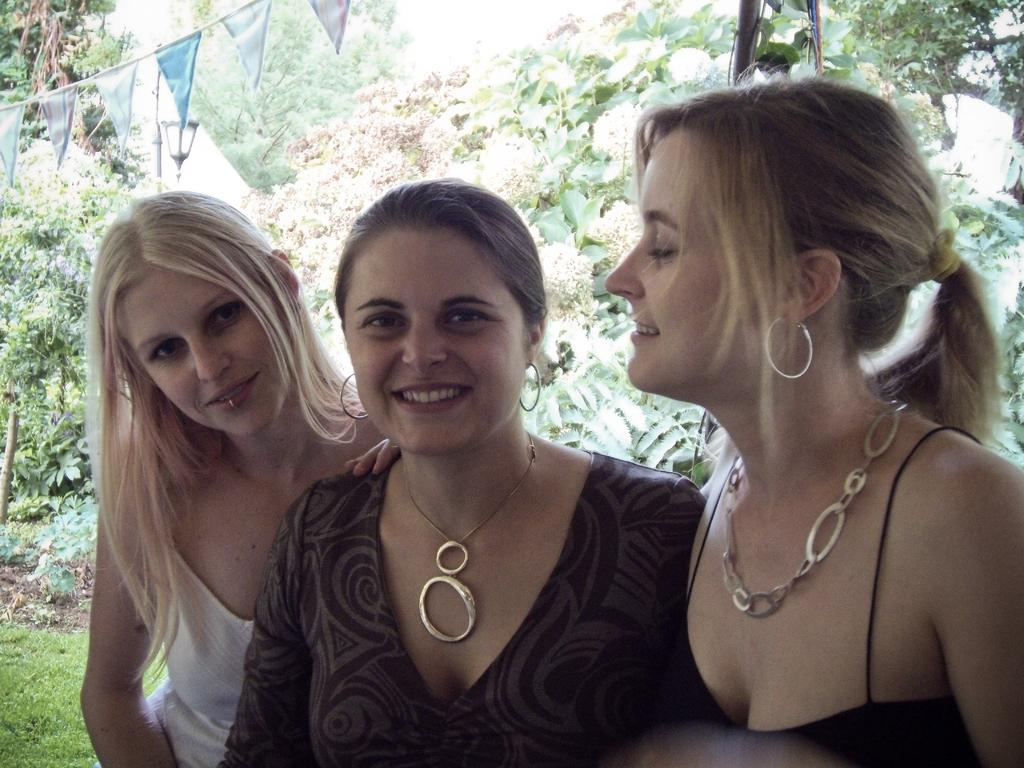What are the people in the image doing? The people in the image are posing for a photo. What can be seen in the background of the image? There are trees in the background of the image. What is the source of light in the image? There is a pole light in the image. What direction are the people in the image helping with science? There is no indication in the image that the people are helping with science or moving in a specific direction. 